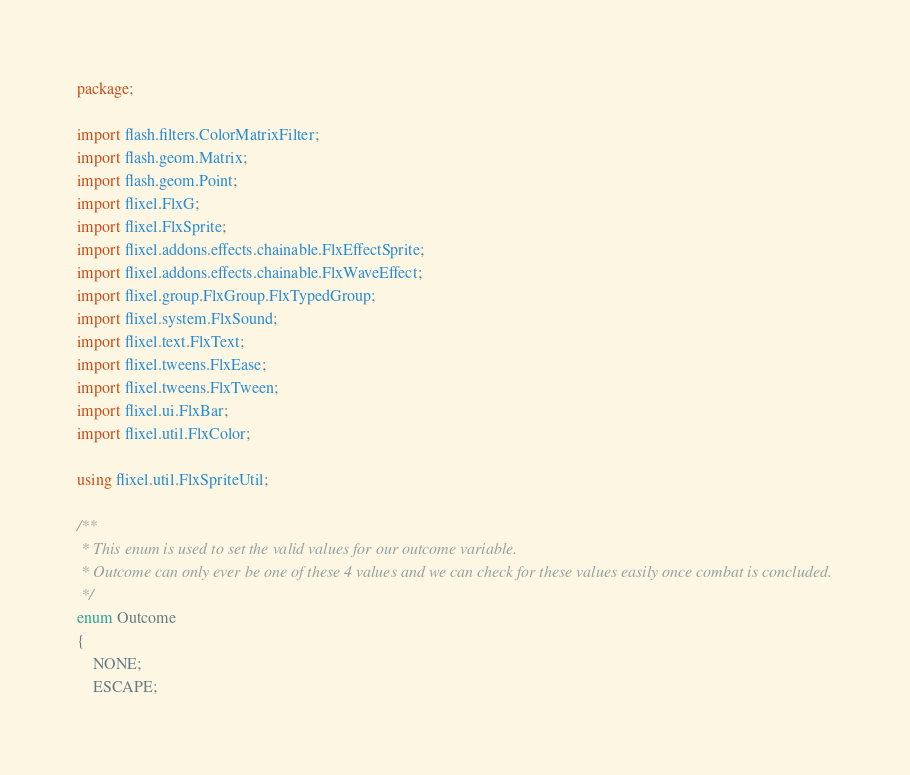<code> <loc_0><loc_0><loc_500><loc_500><_Haxe_>package;

import flash.filters.ColorMatrixFilter;
import flash.geom.Matrix;
import flash.geom.Point;
import flixel.FlxG;
import flixel.FlxSprite;
import flixel.addons.effects.chainable.FlxEffectSprite;
import flixel.addons.effects.chainable.FlxWaveEffect;
import flixel.group.FlxGroup.FlxTypedGroup;
import flixel.system.FlxSound;
import flixel.text.FlxText;
import flixel.tweens.FlxEase;
import flixel.tweens.FlxTween;
import flixel.ui.FlxBar;
import flixel.util.FlxColor;

using flixel.util.FlxSpriteUtil;

/**
 * This enum is used to set the valid values for our outcome variable.
 * Outcome can only ever be one of these 4 values and we can check for these values easily once combat is concluded.
 */
enum Outcome
{
	NONE;
	ESCAPE;</code> 